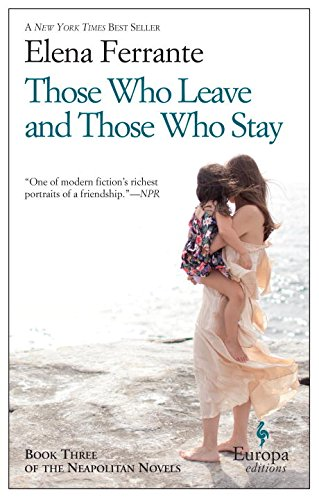Is this a historical book? No, this book is not historical; it focuses more on personal and relational dynamics set against the backdrop of modern-day Italy, rather than historical events. 